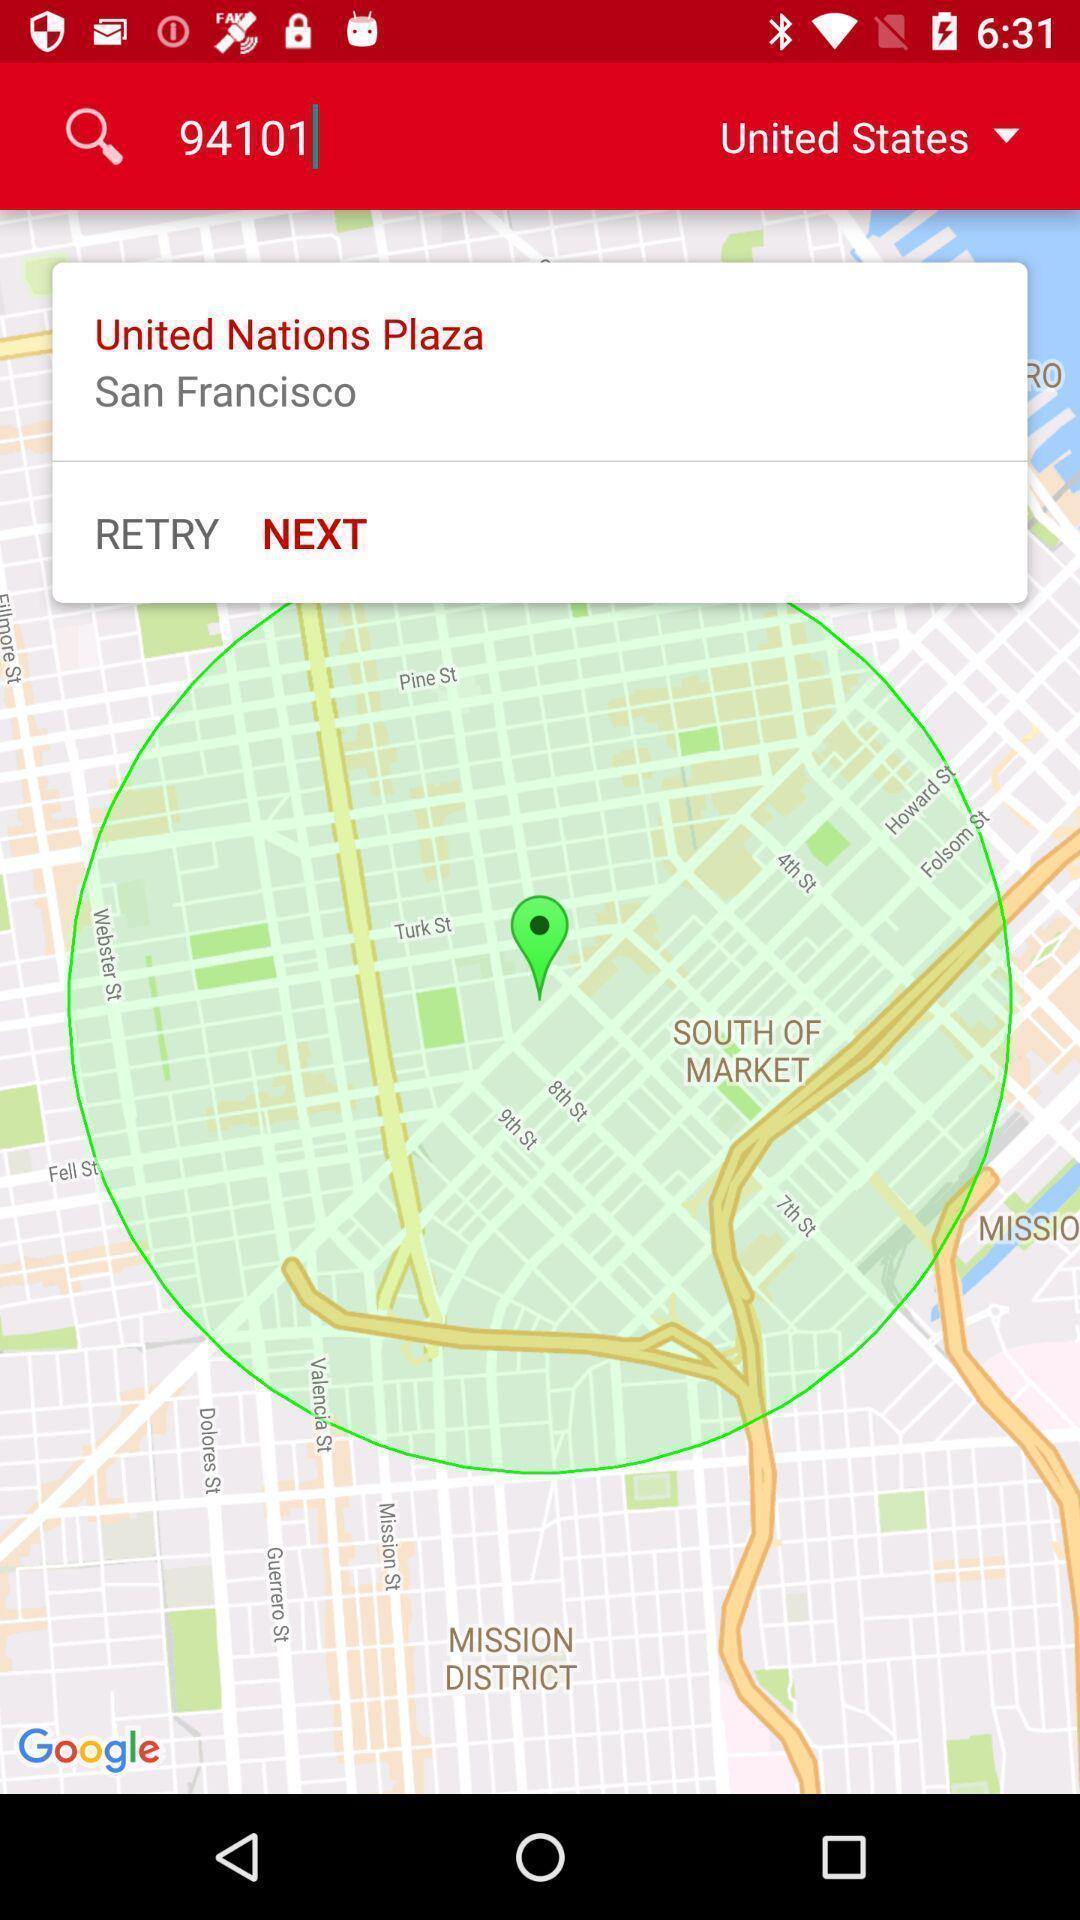Describe the key features of this screenshot. Search bar option page of a weather app. 